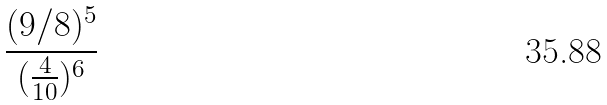Convert formula to latex. <formula><loc_0><loc_0><loc_500><loc_500>\frac { ( 9 / 8 ) ^ { 5 } } { ( \frac { 4 } { 1 0 } ) ^ { 6 } }</formula> 